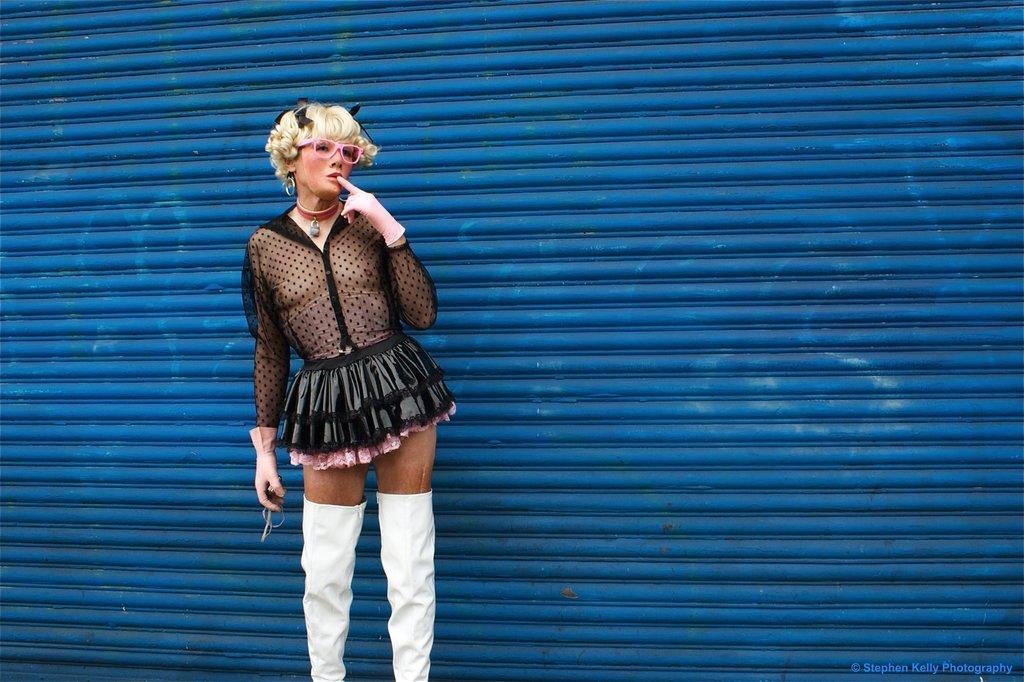Describe this image in one or two sentences. In this image we can see a person standing and holding some objects and in the background, we can see the wall which is in blue color. 